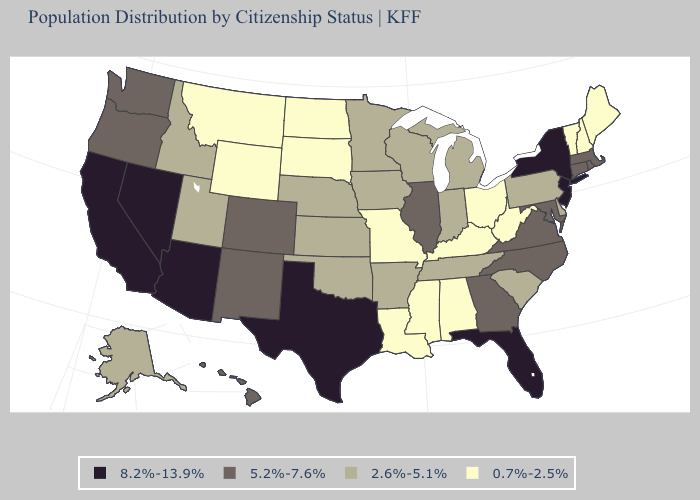Among the states that border Nevada , does Idaho have the lowest value?
Keep it brief. Yes. What is the highest value in the USA?
Concise answer only. 8.2%-13.9%. Which states have the lowest value in the USA?
Short answer required. Alabama, Kentucky, Louisiana, Maine, Mississippi, Missouri, Montana, New Hampshire, North Dakota, Ohio, South Dakota, Vermont, West Virginia, Wyoming. Which states have the highest value in the USA?
Short answer required. Arizona, California, Florida, Nevada, New Jersey, New York, Texas. Which states have the lowest value in the USA?
Answer briefly. Alabama, Kentucky, Louisiana, Maine, Mississippi, Missouri, Montana, New Hampshire, North Dakota, Ohio, South Dakota, Vermont, West Virginia, Wyoming. Which states hav the highest value in the Northeast?
Short answer required. New Jersey, New York. Which states have the lowest value in the South?
Short answer required. Alabama, Kentucky, Louisiana, Mississippi, West Virginia. Name the states that have a value in the range 8.2%-13.9%?
Answer briefly. Arizona, California, Florida, Nevada, New Jersey, New York, Texas. Name the states that have a value in the range 8.2%-13.9%?
Give a very brief answer. Arizona, California, Florida, Nevada, New Jersey, New York, Texas. What is the value of Rhode Island?
Quick response, please. 5.2%-7.6%. Does North Carolina have the lowest value in the South?
Keep it brief. No. What is the lowest value in the South?
Answer briefly. 0.7%-2.5%. Name the states that have a value in the range 5.2%-7.6%?
Answer briefly. Colorado, Connecticut, Georgia, Hawaii, Illinois, Maryland, Massachusetts, New Mexico, North Carolina, Oregon, Rhode Island, Virginia, Washington. Is the legend a continuous bar?
Be succinct. No. 